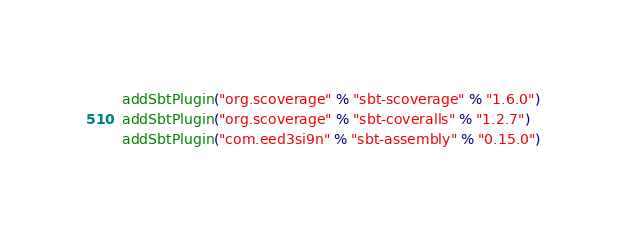<code> <loc_0><loc_0><loc_500><loc_500><_Scala_>addSbtPlugin("org.scoverage" % "sbt-scoverage" % "1.6.0")
addSbtPlugin("org.scoverage" % "sbt-coveralls" % "1.2.7")
addSbtPlugin("com.eed3si9n" % "sbt-assembly" % "0.15.0")
</code> 